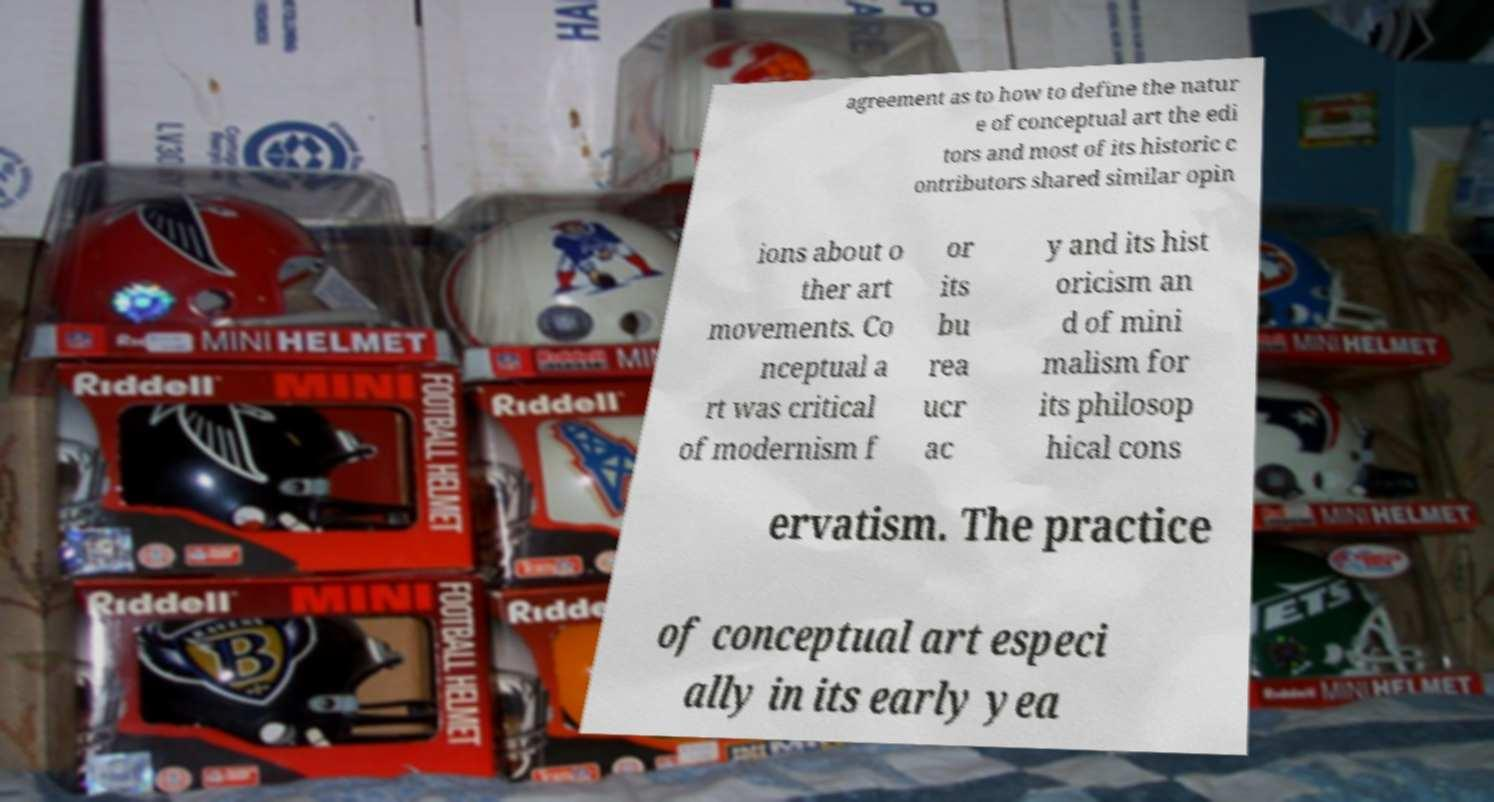Please read and relay the text visible in this image. What does it say? agreement as to how to define the natur e of conceptual art the edi tors and most of its historic c ontributors shared similar opin ions about o ther art movements. Co nceptual a rt was critical of modernism f or its bu rea ucr ac y and its hist oricism an d of mini malism for its philosop hical cons ervatism. The practice of conceptual art especi ally in its early yea 